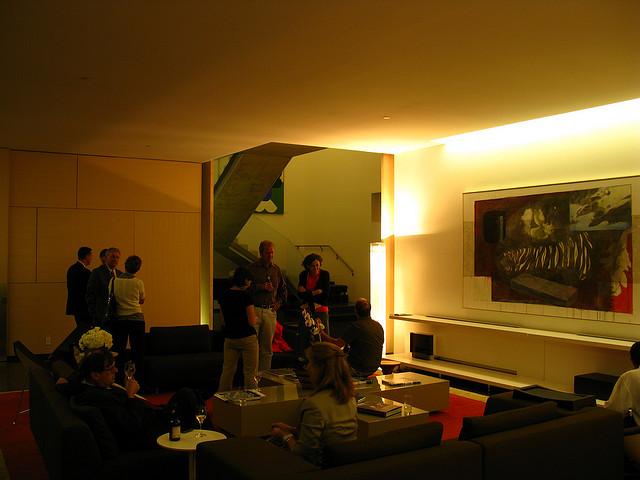Is it a living room?
Give a very brief answer. Yes. Is there art on the wall?
Answer briefly. Yes. Are they having a party?
Short answer required. Yes. Where is the rug?
Write a very short answer. Floor. Are any of these people drinking wine?
Short answer required. Yes. 